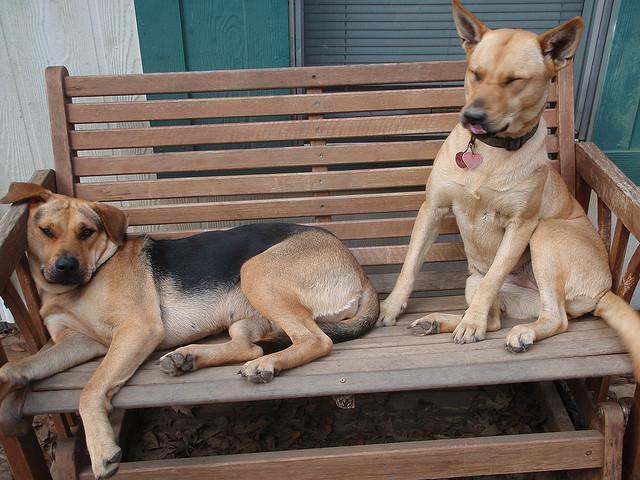How many dogs are in the photo?
Give a very brief answer. 2. 